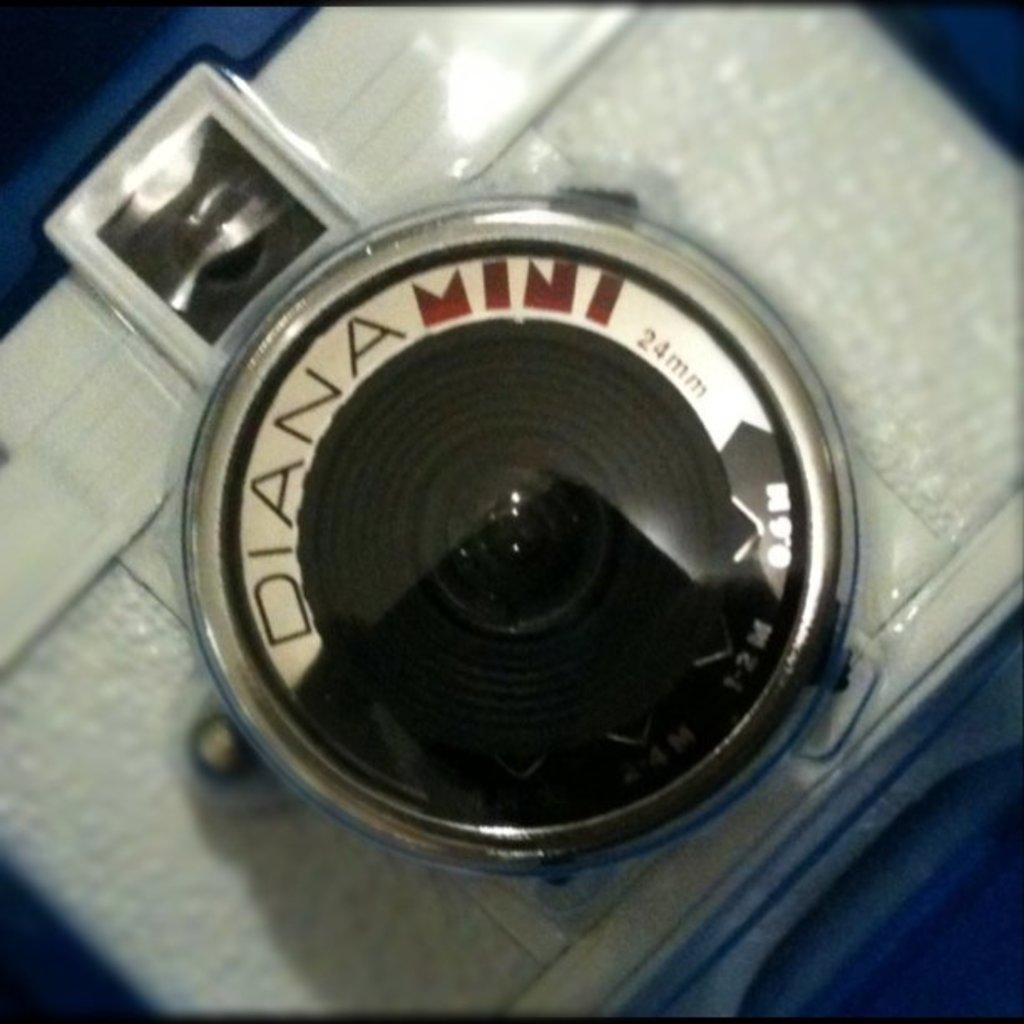In one or two sentences, can you explain what this image depicts? In this image there is some object, and it looks like camera. 